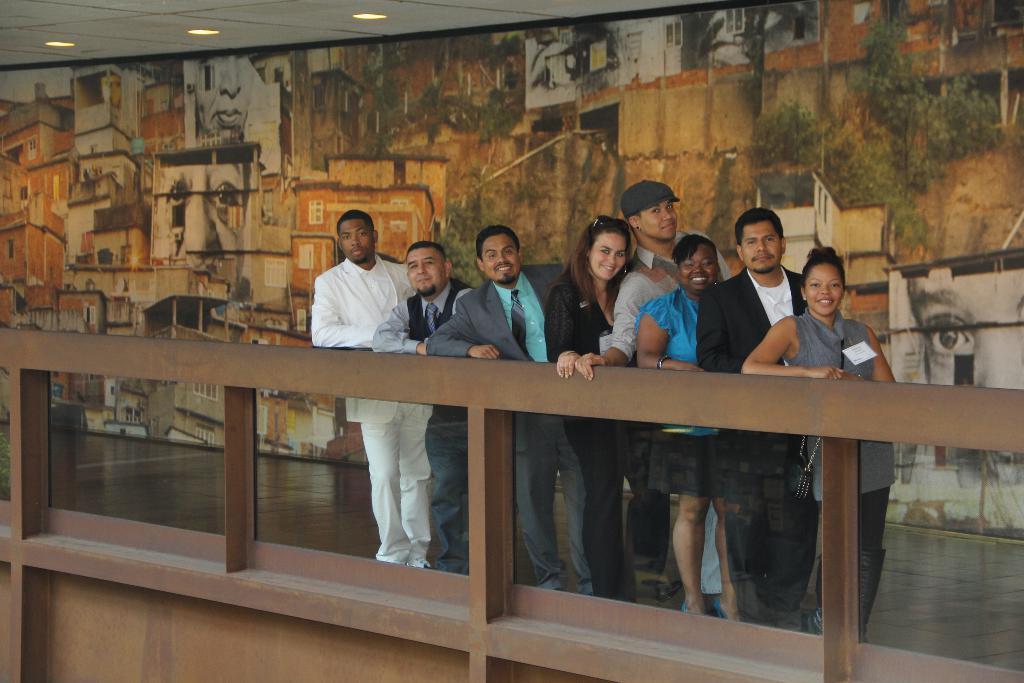Could you give a brief overview of what you see in this image? In this image, we can see a group of people are standing near the glass railing. Few people are smiling. Here a person is wearing a cap. Background there is a wall. Top of the image, we can see the ceiling with lights. 